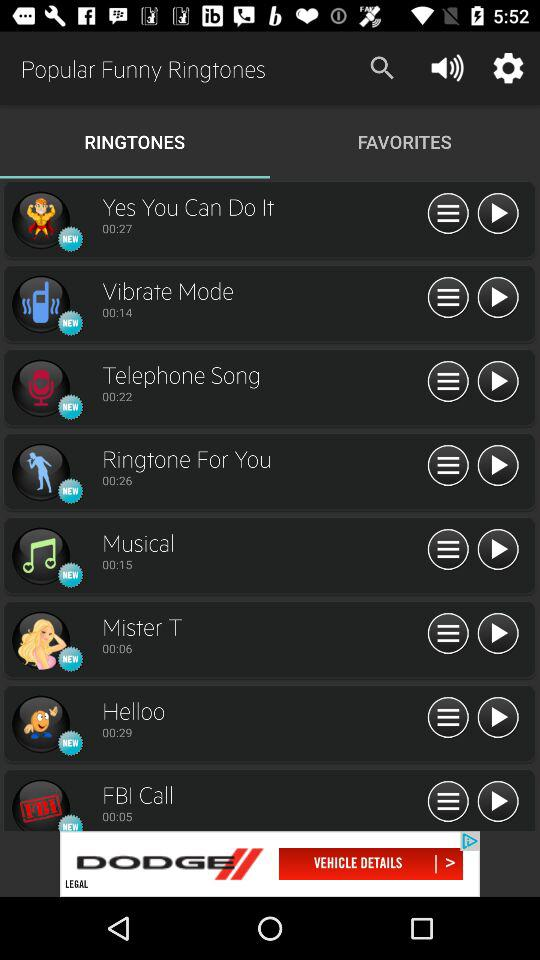How long will the vibrate mode ringtone last? The Vibrate Mode will last for 14 seconds. 